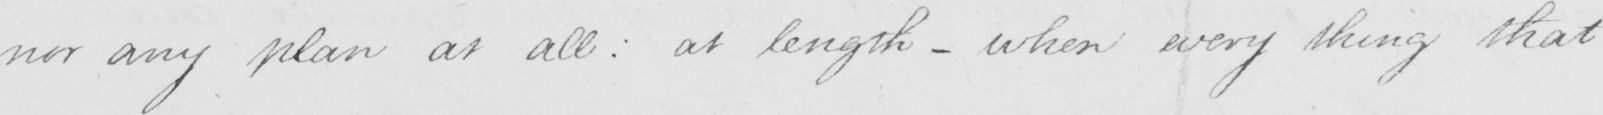Please provide the text content of this handwritten line. nor any plan at all :  at length  _  when every thing that 